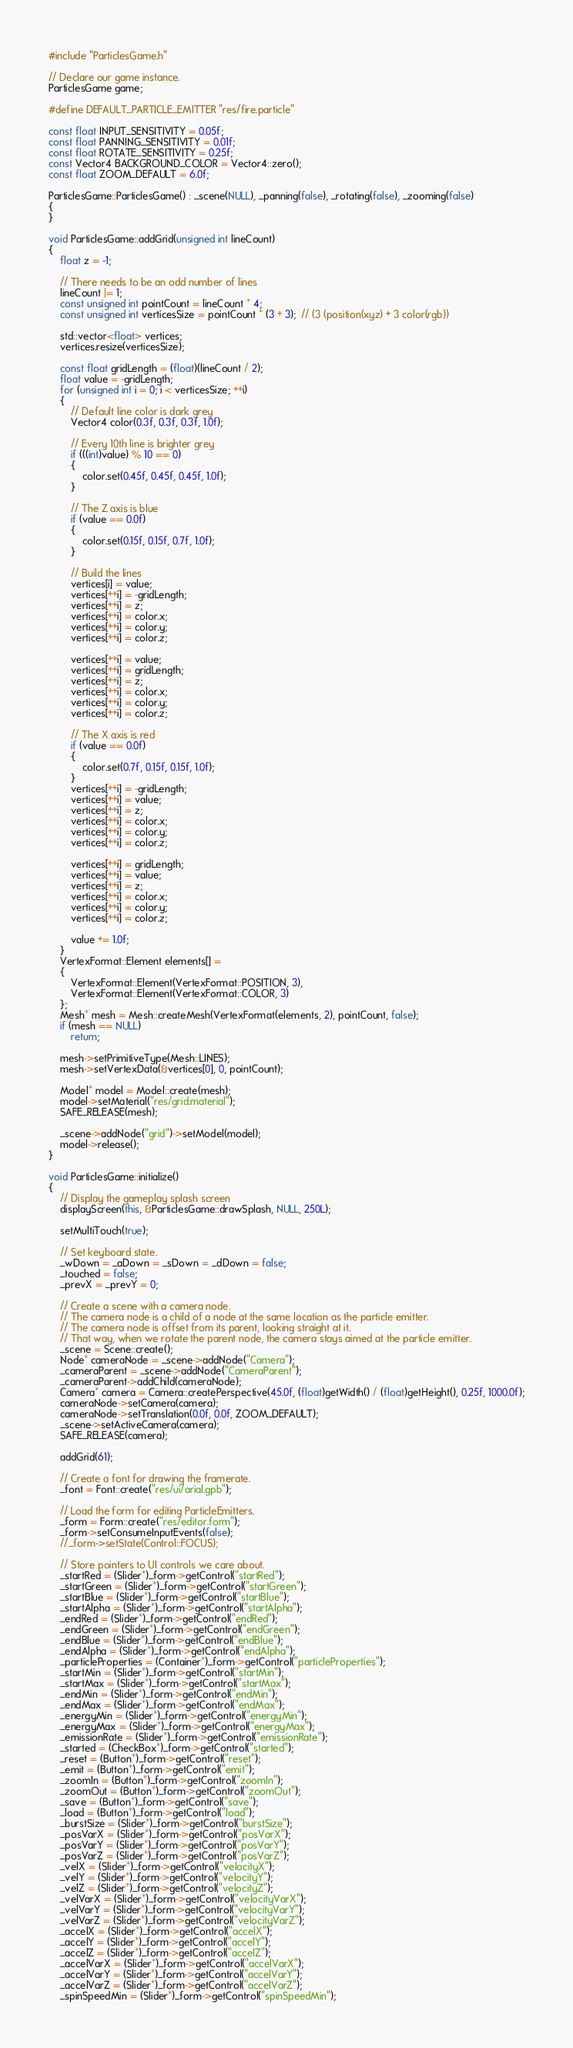<code> <loc_0><loc_0><loc_500><loc_500><_C++_>#include "ParticlesGame.h"

// Declare our game instance.
ParticlesGame game;

#define DEFAULT_PARTICLE_EMITTER "res/fire.particle"

const float INPUT_SENSITIVITY = 0.05f;
const float PANNING_SENSITIVITY = 0.01f;
const float ROTATE_SENSITIVITY = 0.25f;
const Vector4 BACKGROUND_COLOR = Vector4::zero();
const float ZOOM_DEFAULT = 6.0f;

ParticlesGame::ParticlesGame() : _scene(NULL), _panning(false), _rotating(false), _zooming(false)
{
}

void ParticlesGame::addGrid(unsigned int lineCount)
{
    float z = -1;
    
    // There needs to be an odd number of lines
    lineCount |= 1;
    const unsigned int pointCount = lineCount * 4;
    const unsigned int verticesSize = pointCount * (3 + 3);  // (3 (position(xyz) + 3 color(rgb))

    std::vector<float> vertices;
    vertices.resize(verticesSize);

    const float gridLength = (float)(lineCount / 2);
    float value = -gridLength;
    for (unsigned int i = 0; i < verticesSize; ++i)
    {
        // Default line color is dark grey
        Vector4 color(0.3f, 0.3f, 0.3f, 1.0f);

        // Every 10th line is brighter grey
        if (((int)value) % 10 == 0)
        {
            color.set(0.45f, 0.45f, 0.45f, 1.0f);
        }

        // The Z axis is blue
        if (value == 0.0f)
        {
            color.set(0.15f, 0.15f, 0.7f, 1.0f);
        }

        // Build the lines
        vertices[i] = value;
        vertices[++i] = -gridLength;
        vertices[++i] = z;
        vertices[++i] = color.x;
        vertices[++i] = color.y;
        vertices[++i] = color.z;

        vertices[++i] = value;
        vertices[++i] = gridLength;
        vertices[++i] = z;
        vertices[++i] = color.x;
        vertices[++i] = color.y;
        vertices[++i] = color.z;

        // The X axis is red
        if (value == 0.0f)
        {
            color.set(0.7f, 0.15f, 0.15f, 1.0f);
        }
        vertices[++i] = -gridLength;
        vertices[++i] = value;
        vertices[++i] = z;
        vertices[++i] = color.x;
        vertices[++i] = color.y;
        vertices[++i] = color.z;

        vertices[++i] = gridLength;
        vertices[++i] = value;
        vertices[++i] = z;
        vertices[++i] = color.x;
        vertices[++i] = color.y;
        vertices[++i] = color.z;

        value += 1.0f;
    }
    VertexFormat::Element elements[] =
    {
        VertexFormat::Element(VertexFormat::POSITION, 3),
        VertexFormat::Element(VertexFormat::COLOR, 3)
    };
    Mesh* mesh = Mesh::createMesh(VertexFormat(elements, 2), pointCount, false);
    if (mesh == NULL)
        return;

    mesh->setPrimitiveType(Mesh::LINES);
    mesh->setVertexData(&vertices[0], 0, pointCount);

    Model* model = Model::create(mesh);
    model->setMaterial("res/grid.material");
    SAFE_RELEASE(mesh);

    _scene->addNode("grid")->setModel(model);
    model->release();
}

void ParticlesGame::initialize()
{
    // Display the gameplay splash screen
    displayScreen(this, &ParticlesGame::drawSplash, NULL, 250L);

    setMultiTouch(true);

    // Set keyboard state.
    _wDown = _aDown = _sDown = _dDown = false;
    _touched = false;
    _prevX = _prevY = 0;

    // Create a scene with a camera node.
    // The camera node is a child of a node at the same location as the particle emitter.
    // The camera node is offset from its parent, looking straight at it.
    // That way, when we rotate the parent node, the camera stays aimed at the particle emitter.
    _scene = Scene::create();
    Node* cameraNode = _scene->addNode("Camera");
    _cameraParent = _scene->addNode("CameraParent");
    _cameraParent->addChild(cameraNode);
    Camera* camera = Camera::createPerspective(45.0f, (float)getWidth() / (float)getHeight(), 0.25f, 1000.0f);
    cameraNode->setCamera(camera);
    cameraNode->setTranslation(0.0f, 0.0f, ZOOM_DEFAULT);
    _scene->setActiveCamera(camera);
    SAFE_RELEASE(camera);

    addGrid(61);

    // Create a font for drawing the framerate.
    _font = Font::create("res/ui/arial.gpb");

    // Load the form for editing ParticleEmitters.
    _form = Form::create("res/editor.form");
    _form->setConsumeInputEvents(false);
    //_form->setState(Control::FOCUS);

    // Store pointers to UI controls we care about.
    _startRed = (Slider*)_form->getControl("startRed");
    _startGreen = (Slider*)_form->getControl("startGreen");
    _startBlue = (Slider*)_form->getControl("startBlue");
    _startAlpha = (Slider*)_form->getControl("startAlpha");
    _endRed = (Slider*)_form->getControl("endRed");
    _endGreen = (Slider*)_form->getControl("endGreen");
    _endBlue = (Slider*)_form->getControl("endBlue");
    _endAlpha = (Slider*)_form->getControl("endAlpha");
    _particleProperties = (Container*)_form->getControl("particleProperties");
    _startMin = (Slider*)_form->getControl("startMin");
    _startMax = (Slider*)_form->getControl("startMax");
    _endMin = (Slider*)_form->getControl("endMin");
    _endMax = (Slider*)_form->getControl("endMax");
    _energyMin = (Slider*)_form->getControl("energyMin");
    _energyMax = (Slider*)_form->getControl("energyMax");
    _emissionRate = (Slider*)_form->getControl("emissionRate");
    _started = (CheckBox*)_form->getControl("started");
    _reset = (Button*)_form->getControl("reset");
    _emit = (Button*)_form->getControl("emit");
    _zoomIn = (Button*)_form->getControl("zoomIn");
    _zoomOut = (Button*)_form->getControl("zoomOut");
    _save = (Button*)_form->getControl("save");
    _load = (Button*)_form->getControl("load");
    _burstSize = (Slider*)_form->getControl("burstSize");
    _posVarX = (Slider*)_form->getControl("posVarX");
    _posVarY = (Slider*)_form->getControl("posVarY");
    _posVarZ = (Slider*)_form->getControl("posVarZ");
    _velX = (Slider*)_form->getControl("velocityX");
    _velY = (Slider*)_form->getControl("velocityY");
    _velZ = (Slider*)_form->getControl("velocityZ");
    _velVarX = (Slider*)_form->getControl("velocityVarX");
    _velVarY = (Slider*)_form->getControl("velocityVarY");
    _velVarZ = (Slider*)_form->getControl("velocityVarZ");
    _accelX = (Slider*)_form->getControl("accelX");
    _accelY = (Slider*)_form->getControl("accelY");
    _accelZ = (Slider*)_form->getControl("accelZ");
    _accelVarX = (Slider*)_form->getControl("accelVarX");
    _accelVarY = (Slider*)_form->getControl("accelVarY");
    _accelVarZ = (Slider*)_form->getControl("accelVarZ");
    _spinSpeedMin = (Slider*)_form->getControl("spinSpeedMin");</code> 